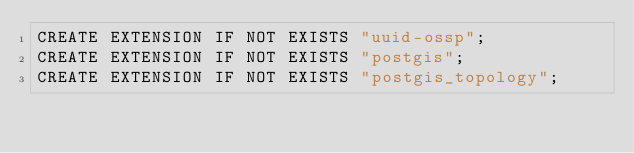<code> <loc_0><loc_0><loc_500><loc_500><_SQL_>CREATE EXTENSION IF NOT EXISTS "uuid-ossp";
CREATE EXTENSION IF NOT EXISTS "postgis";
CREATE EXTENSION IF NOT EXISTS "postgis_topology";</code> 